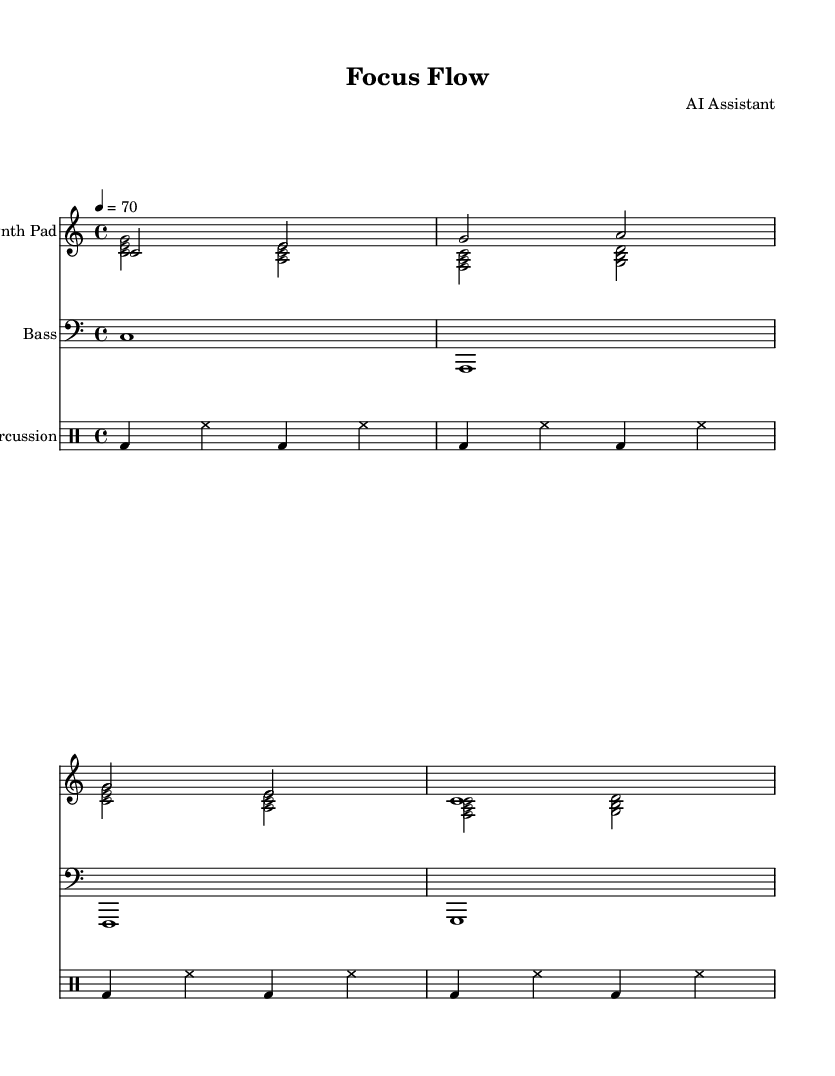What is the key signature of this music? The key signature indicated in the music sheet is C major, which has no sharps or flats.
Answer: C major What is the time signature of this composition? The time signature shown in the music sheet is 4/4, which means there are four beats in each measure.
Answer: 4/4 What is the tempo marking for this piece? The tempo marking is given as quarter note equals 70, indicating a moderately slow pace.
Answer: 70 How many measures are there for the synth pad part? By counting the measures in the synth pad part, there are four measures total in the provided notation.
Answer: 4 Which instruments are featured in this score? The score features a synth pad, bass, and percussion, all specified in separate staves.
Answer: Synth pad, bass, percussion What is the duration of the first note in the bass part? The first note in the bass part is a whole note, which holds for the entire measure, indicated by the notation.
Answer: Whole note What type of music does this sheet represent? This sheet represents ambient electronic music, designed to create a focused atmosphere suitable for product demonstrations.
Answer: Ambient electronic music 